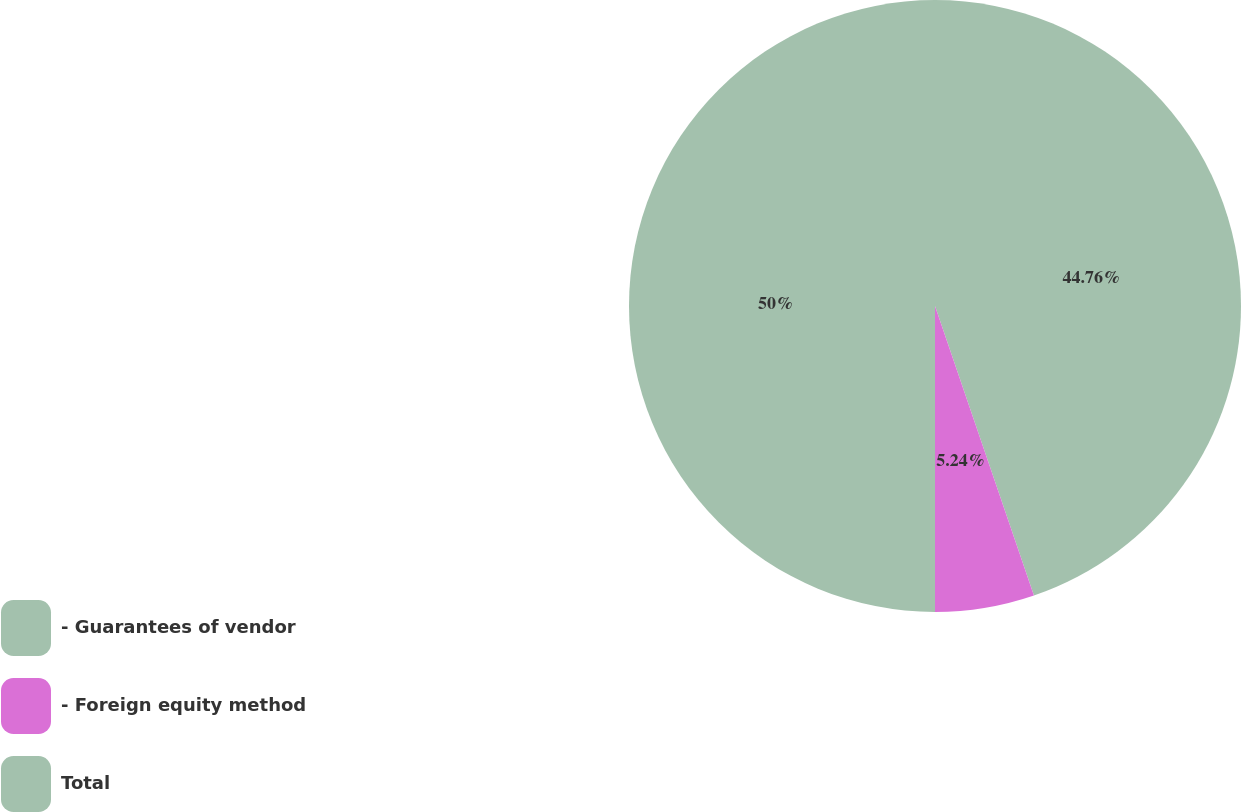Convert chart. <chart><loc_0><loc_0><loc_500><loc_500><pie_chart><fcel>- Guarantees of vendor<fcel>- Foreign equity method<fcel>Total<nl><fcel>44.76%<fcel>5.24%<fcel>50.0%<nl></chart> 